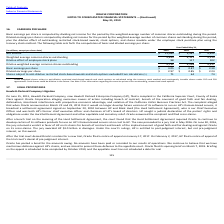According to Oracle Corporation's financial document, How is basic earnings per share calculated? Basic earnings per share is computed by dividing net income for the period by the weighted-average number of common shares outstanding during the period.. The document states: "Basic earnings per share is computed by dividing net income for the period by the weighted-average number of common shares outstanding during the peri..." Also, Does the table show the calculations for basic or diluted earnings per share, or both? The following table sets forth the computation of basic and diluted earnings per share. The document states: "ck purchase plan using the treasury stock method. The following table sets forth the computation of basic and diluted earnings per share:..." Also, Which note should be referred to for information regarding the exercise prices of the company's outstanding, unexercised stock options? See Note 13 for information regarding the exercise prices of our outstanding, unexercised stock options.. The document states: "ents. Such shares could be dilutive in the future. See Note 13 for information regarding the exercise prices of our outstanding, unexercised stock opt..." Also, can you calculate: By how much did net income change from 2018 to 2019? Based on the calculation: 11,083-3,587 , the result is 7496 (in millions). This is based on the information: "Net income $ 11,083 $ 3,587 $ 9,452 Net income $ 11,083 $ 3,587 $ 9,452..." The key data points involved are: 11,083, 3,587. Also, can you calculate: In 2019, how much more was the basic earnings per share than the diluted earnings per share? Based on the calculation: 3.05-2.97 , the result is 0.08. This is based on the information: "Basic earnings per share $ 3.05 $ 0.87 $ 2.30 Diluted earnings per share $ 2.97 $ 0.85 $ 2.24..." The key data points involved are: 2.97, 3.05. Also, can you calculate: What was the percentage change in dilutive effect of employee stock plans from 2017 to 2018? To answer this question, I need to perform calculations using the financial data. The calculation is: (117-102)/102 , which equals 14.71 (percentage). This is based on the information: "Dilutive effect of employee stock plans 98 117 102 Dilutive effect of employee stock plans 98 117 102..." The key data points involved are: 102, 117. 